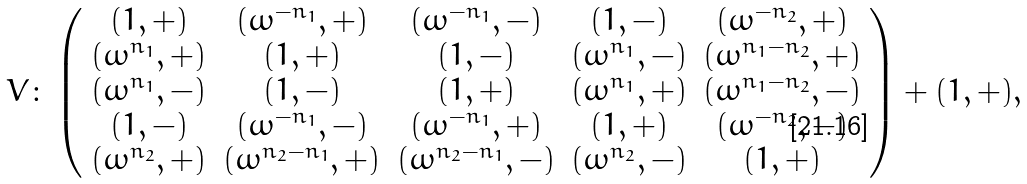Convert formula to latex. <formula><loc_0><loc_0><loc_500><loc_500>V \colon \left ( \begin{array} { c c c c c } ( 1 , + ) & ( \omega ^ { - n _ { 1 } } , + ) & ( \omega ^ { - n _ { 1 } } , - ) & ( 1 , - ) & ( \omega ^ { - n _ { 2 } } , + ) \\ ( \omega ^ { n _ { 1 } } , + ) & ( 1 , + ) & ( 1 , - ) & ( \omega ^ { n _ { 1 } } , - ) & ( \omega ^ { n _ { 1 } - n _ { 2 } } , + ) \\ ( \omega ^ { n _ { 1 } } , - ) & ( 1 , - ) & ( 1 , + ) & ( \omega ^ { n _ { 1 } } , + ) & ( \omega ^ { n _ { 1 } - n _ { 2 } } , - ) \\ ( 1 , - ) & ( \omega ^ { - n _ { 1 } } , - ) & ( \omega ^ { - n _ { 1 } } , + ) & ( 1 , + ) & ( \omega ^ { - n _ { 2 } } , - ) \\ ( \omega ^ { n _ { 2 } } , + ) & ( \omega ^ { n _ { 2 } - n _ { 1 } } , + ) & ( \omega ^ { n _ { 2 } - n _ { 1 } } , - ) & ( \omega ^ { n _ { 2 } } , - ) & ( 1 , + ) \end{array} \right ) + ( 1 , + ) , \,</formula> 